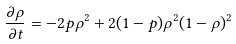Convert formula to latex. <formula><loc_0><loc_0><loc_500><loc_500>\frac { \partial \rho } { \partial t } = - 2 p \rho ^ { 2 } + 2 ( 1 - p ) \rho ^ { 2 } ( 1 - \rho ) ^ { 2 }</formula> 